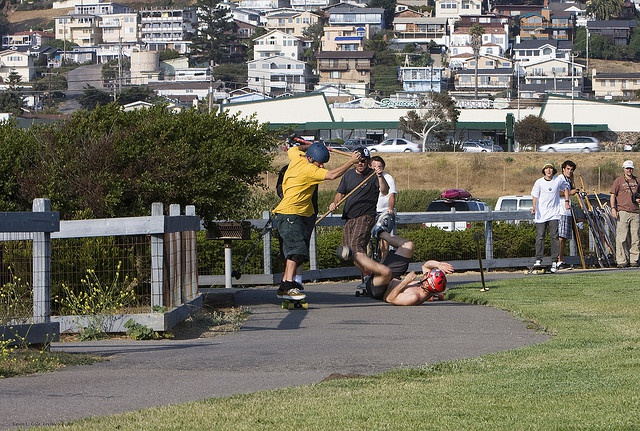Describe the objects in this image and their specific colors. I can see people in black, gold, gray, and tan tones, people in black, gray, tan, and maroon tones, people in black and gray tones, people in black, lavender, gray, and darkgray tones, and people in black, darkgray, and gray tones in this image. 